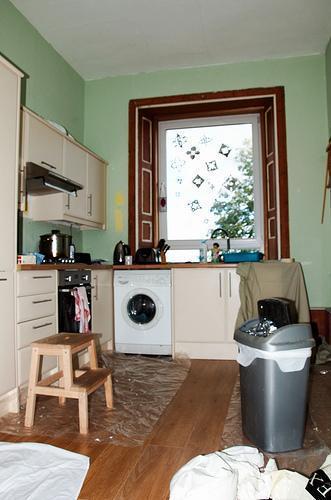How many plastic tarps?
Give a very brief answer. 2. How many people are cooking at the stove?
Give a very brief answer. 0. 